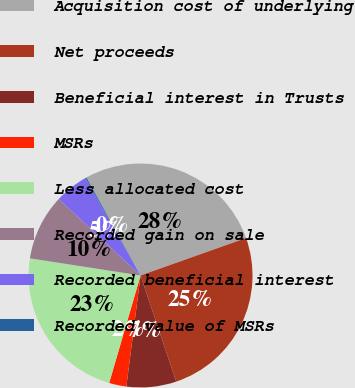Convert chart. <chart><loc_0><loc_0><loc_500><loc_500><pie_chart><fcel>Acquisition cost of underlying<fcel>Net proceeds<fcel>Beneficial interest in Trusts<fcel>MSRs<fcel>Less allocated cost<fcel>Recorded gain on sale<fcel>Recorded beneficial interest<fcel>Recorded value of MSRs<nl><fcel>27.61%<fcel>25.27%<fcel>7.18%<fcel>2.5%<fcel>22.93%<fcel>9.52%<fcel>4.84%<fcel>0.16%<nl></chart> 